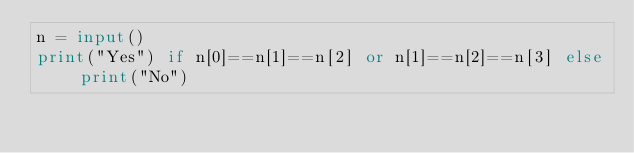<code> <loc_0><loc_0><loc_500><loc_500><_Python_>n = input()
print("Yes") if n[0]==n[1]==n[2] or n[1]==n[2]==n[3] else print("No")</code> 